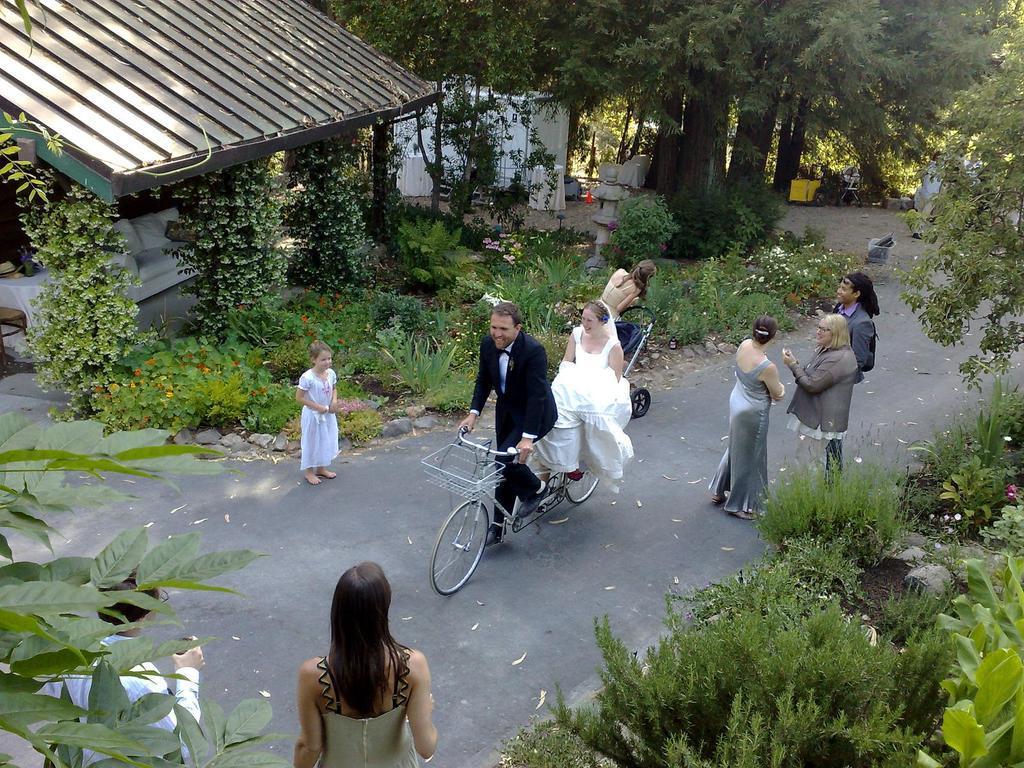In one or two sentences, can you explain what this image depicts? In this image there are group of persons standing on the road at the middle of the image there are two persons who are riding on a bicycle and at the background of the image there is a house and trees. 